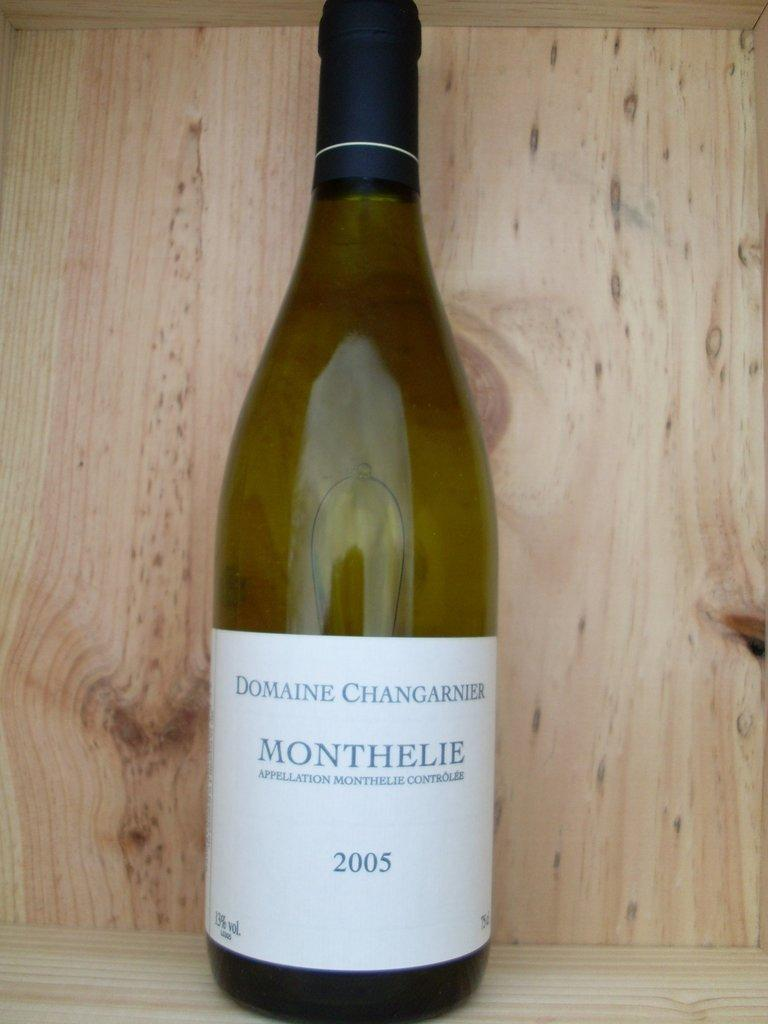<image>
Give a short and clear explanation of the subsequent image. A bottle of wine says "MONTHELIE" on the label. 